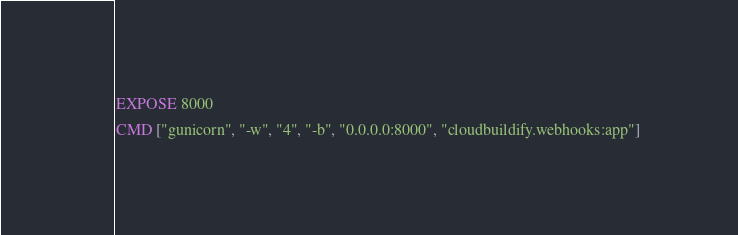Convert code to text. <code><loc_0><loc_0><loc_500><loc_500><_Dockerfile_>
EXPOSE 8000

CMD ["gunicorn", "-w", "4", "-b", "0.0.0.0:8000", "cloudbuildify.webhooks:app"]
</code> 